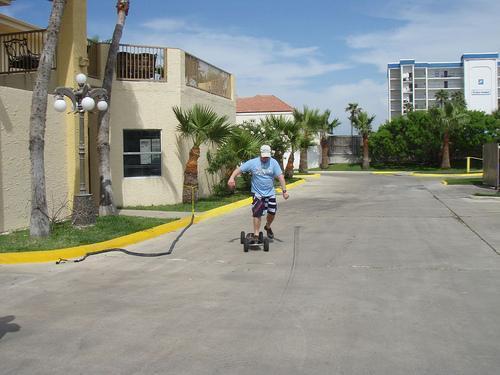How many boys are showing?
Give a very brief answer. 1. 